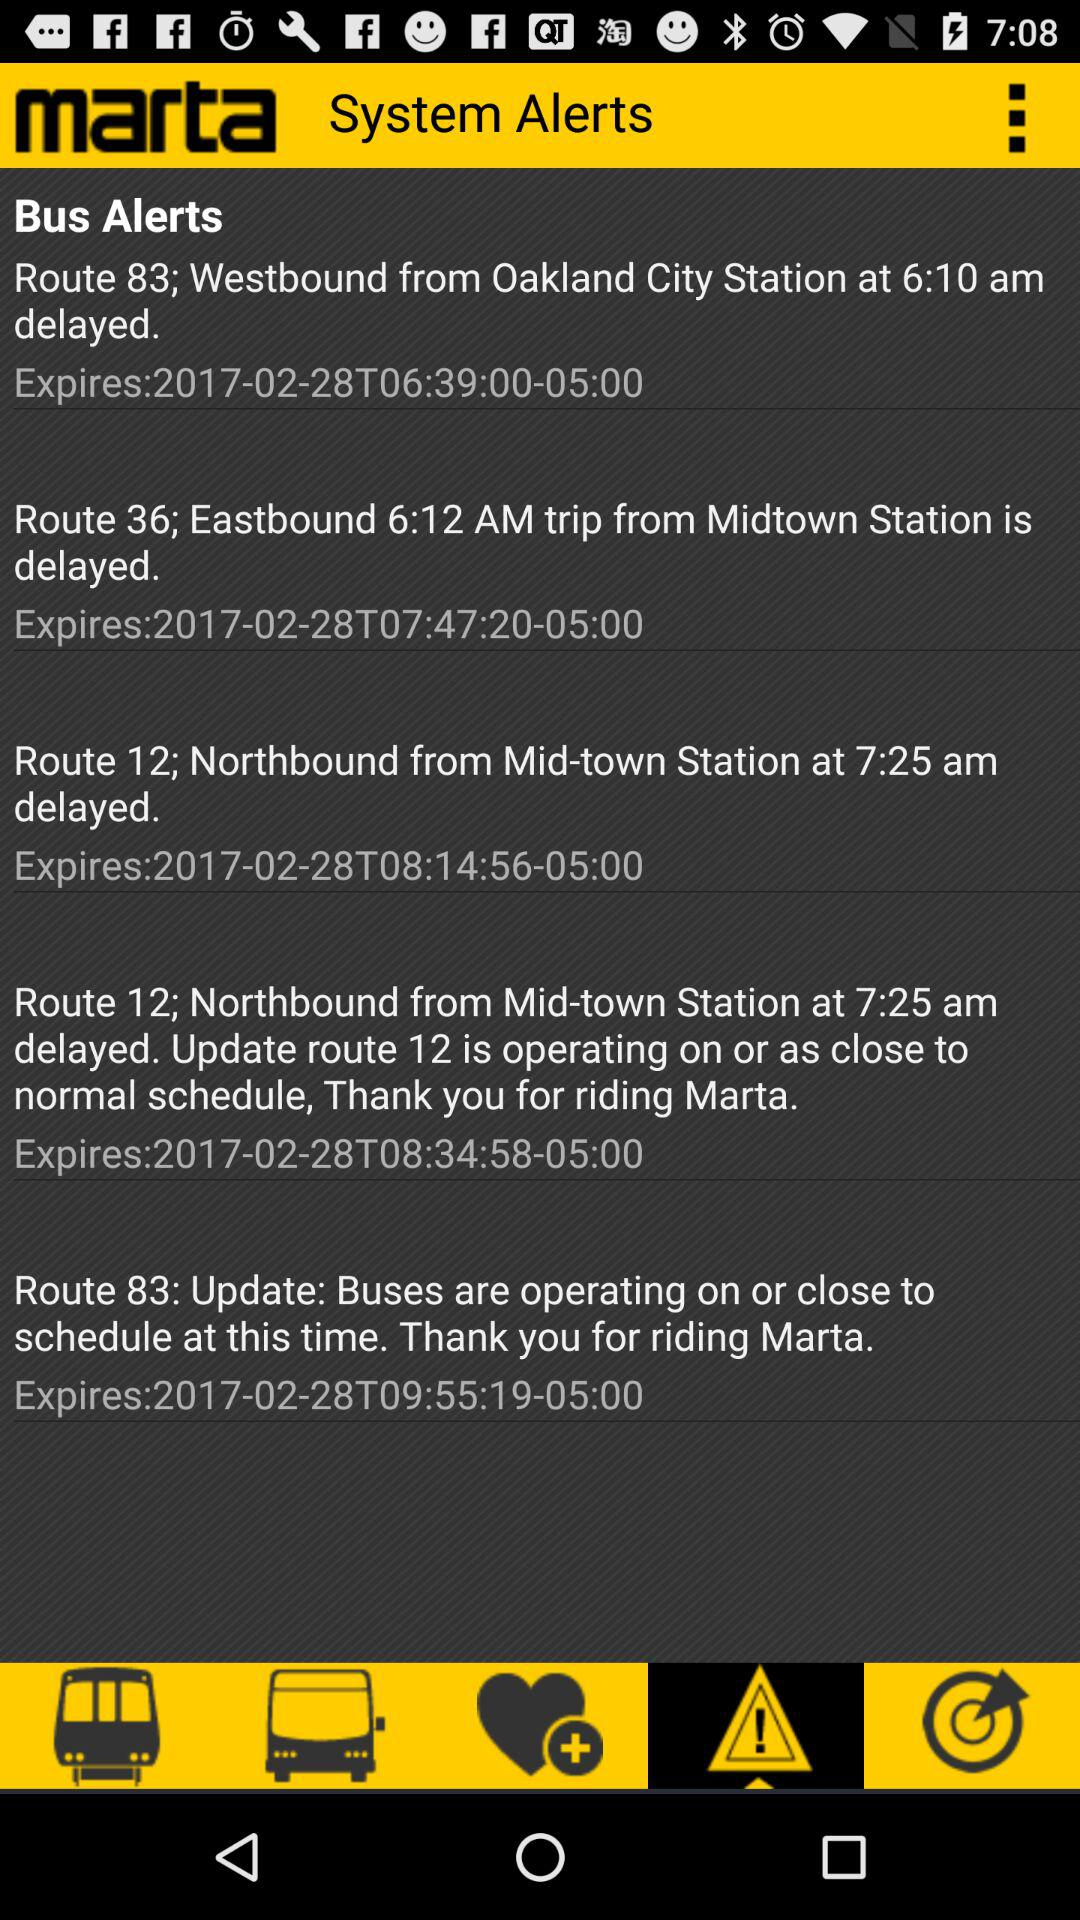What version of the application is being used?
When the provided information is insufficient, respond with <no answer>. <no answer> 